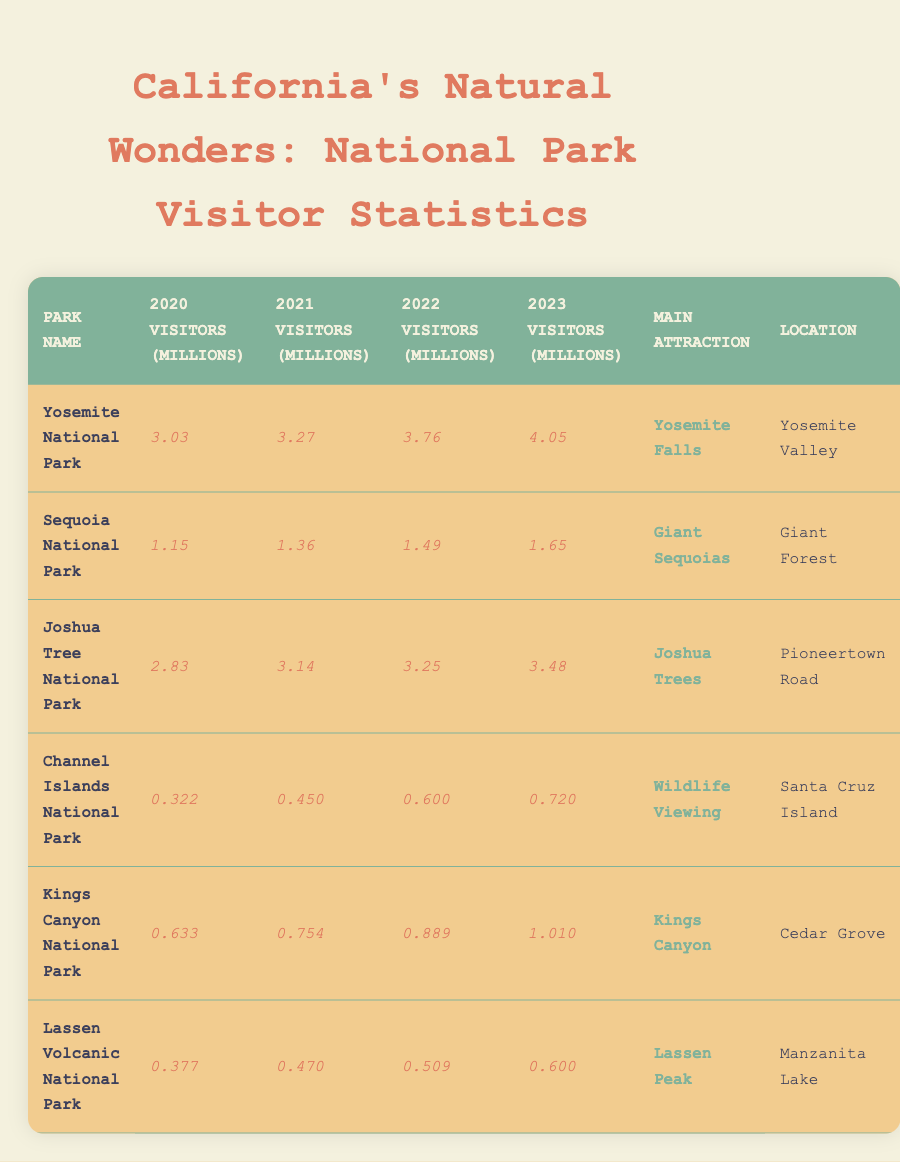What was the main attraction of Yosemite National Park? In the table, the main attraction for Yosemite National Park is listed alongside its visitor statistics.
Answer: Yosemite Falls How many visitors did Joshua Tree National Park have in 2022? The value for 2022 visitors for Joshua Tree National Park is found in the corresponding column labeled for that year.
Answer: 3.25 million Which national park had the highest number of visitors in 2023? By comparing the 2023 visitor numbers for all parks in the table, Yosemite National Park has the highest figure at 4.05 million visitors.
Answer: Yosemite National Park What was the total number of visitors for Kings Canyon National Park from 2020 to 2023? Adding the visitor counts from each year: 0.633 + 0.754 + 0.889 + 1.010 equals 3.286 million visitors total across the four years.
Answer: 3.286 million Did Sequoia National Park's annual visitors increase every year from 2020 to 2023? Each year listed in the table shows increasing visitor numbers: 1.15 (2020) to 1.36 (2021) to 1.49 (2022) to 1.65 (2023). Therefore, it did increase every year.
Answer: Yes What is the average number of visitors over the four years for Channel Islands National Park? To find the average, add the visitor numbers for all four years (0.322 + 0.450 + 0.600 + 0.720) which equals 2.092 million. Divide by 4 gives 0.523 million visitors on average.
Answer: 0.523 million Which national park had the lowest number of visitors in 2020? The visitor numbers for 2020 indicate that Channel Islands National Park had 0.322 million visitors, which is the lowest compared to others.
Answer: Channel Islands National Park How many more visitors did Yosemite National Park have in 2023 compared to 2020? To calculate the difference, subtract the 2020 visitors (3.03) from the 2023 visitors (4.05), resulting in a change of 1.02 million more visitors.
Answer: 1.02 million What is the trend of visitors for Lassen Volcanic National Park from 2020 to 2023? The visitor numbers for Lassen Volcanic National Park show a gradual increase each year: from 0.377 (2020) to 0.600 (2023). This indicates a positive trend in visitor numbers.
Answer: Increasing What was the total number of visitors across all parks in 2023? The total for 2023 can be found by adding all the visitor numbers in that column: 4.05 (Yosemite) + 1.65 (Sequoia) + 3.48 (Joshua Tree) + 0.720 (Channel Islands) + 1.010 (Kings Canyon) + 0.600 (Lassen) equals 11.58 million.
Answer: 11.58 million 